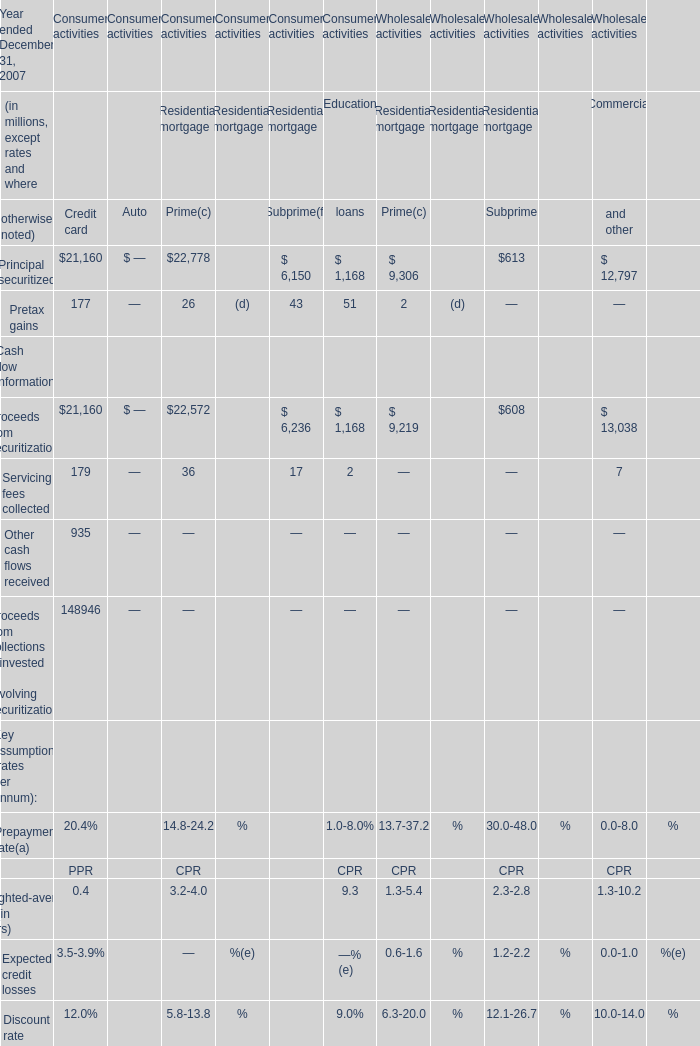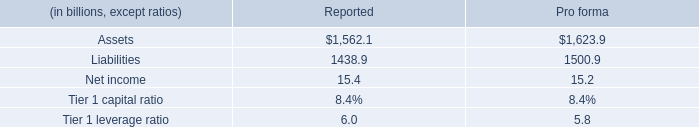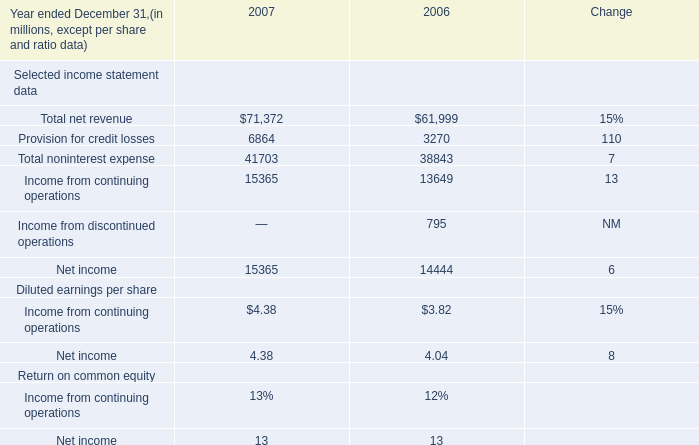What is the total amount of Provision for credit losses of 2006, Principal securitized of Wholesale activities Residential mortgage Prime is, and Liabilities of Reported ? 
Computations: ((3270.0 + 9306.0) + 1438.9)
Answer: 14014.9. 